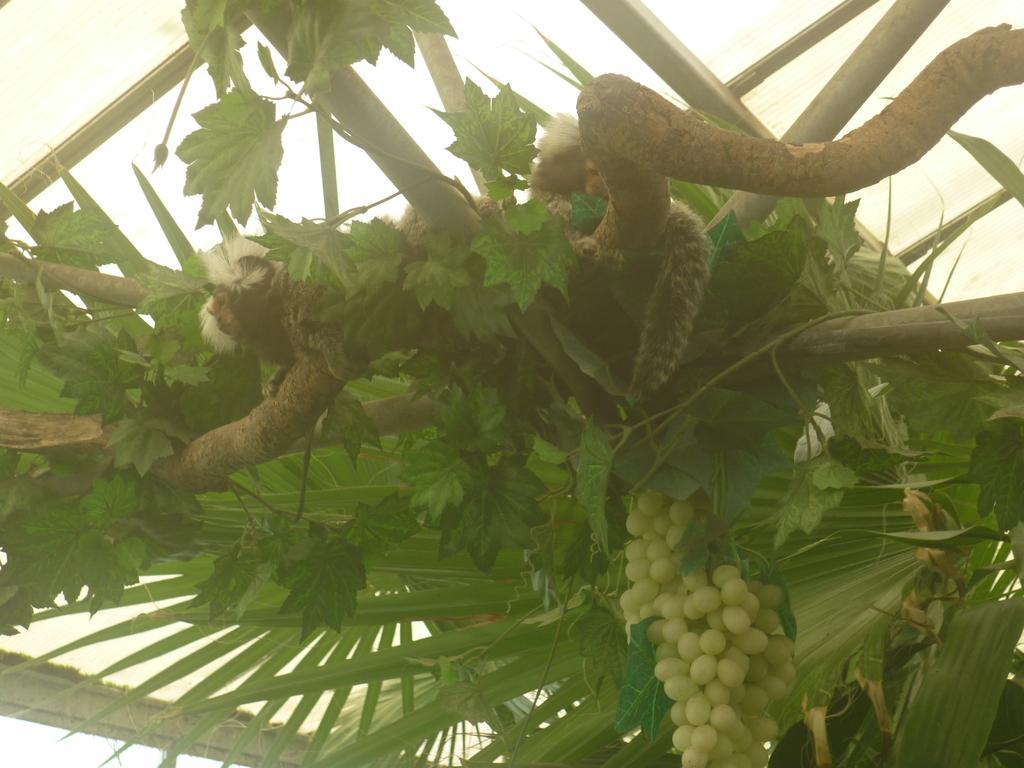Can you describe this image briefly? The picture consists of a grape tree and wooden poles. At the bottom there are grapes. On the tree there are some animals. At the top it is ceiling. 